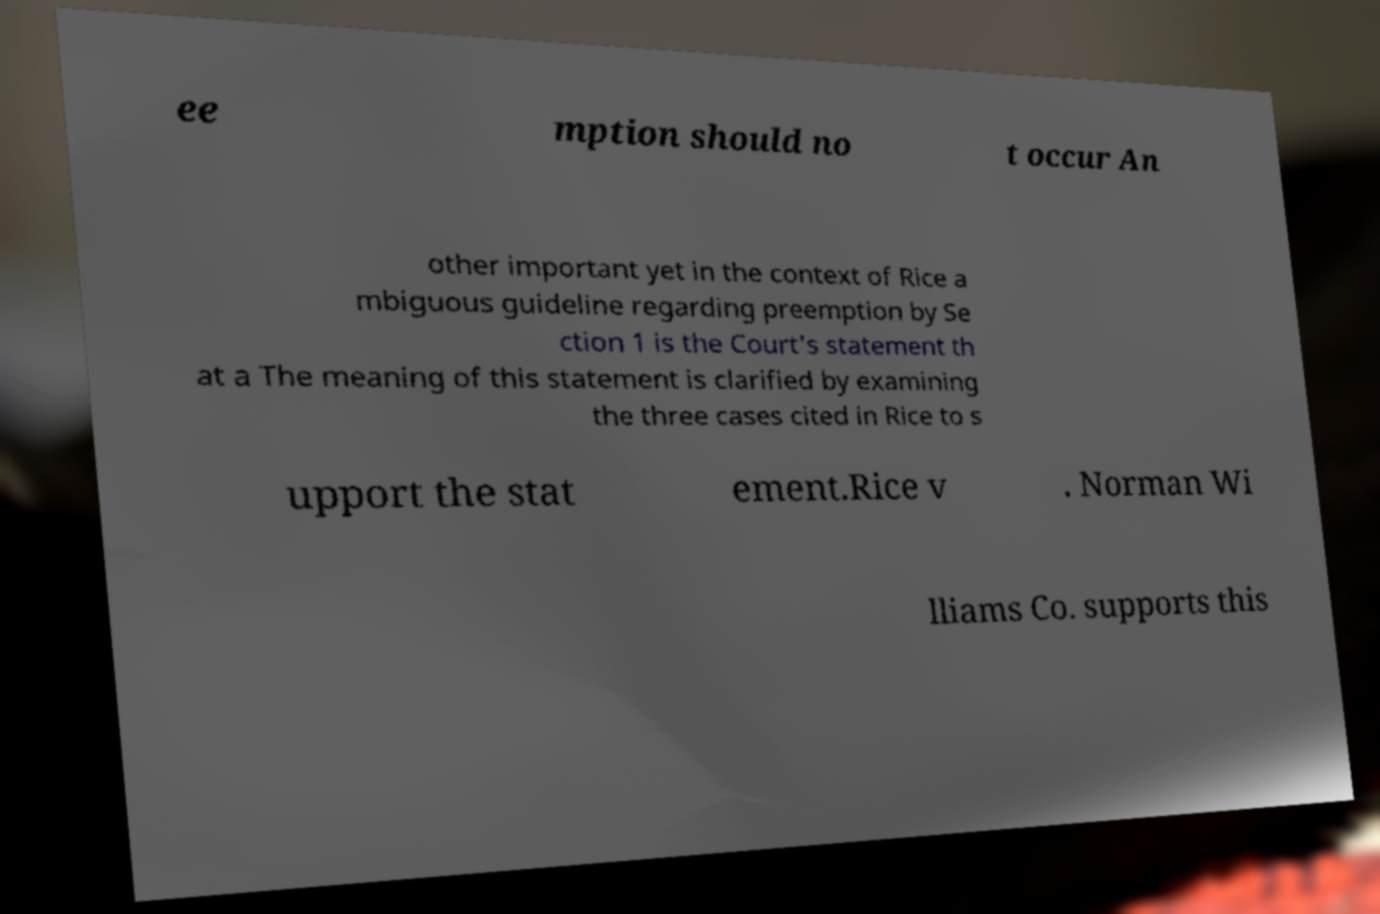There's text embedded in this image that I need extracted. Can you transcribe it verbatim? ee mption should no t occur An other important yet in the context of Rice a mbiguous guideline regarding preemption by Se ction 1 is the Court's statement th at a The meaning of this statement is clarified by examining the three cases cited in Rice to s upport the stat ement.Rice v . Norman Wi lliams Co. supports this 